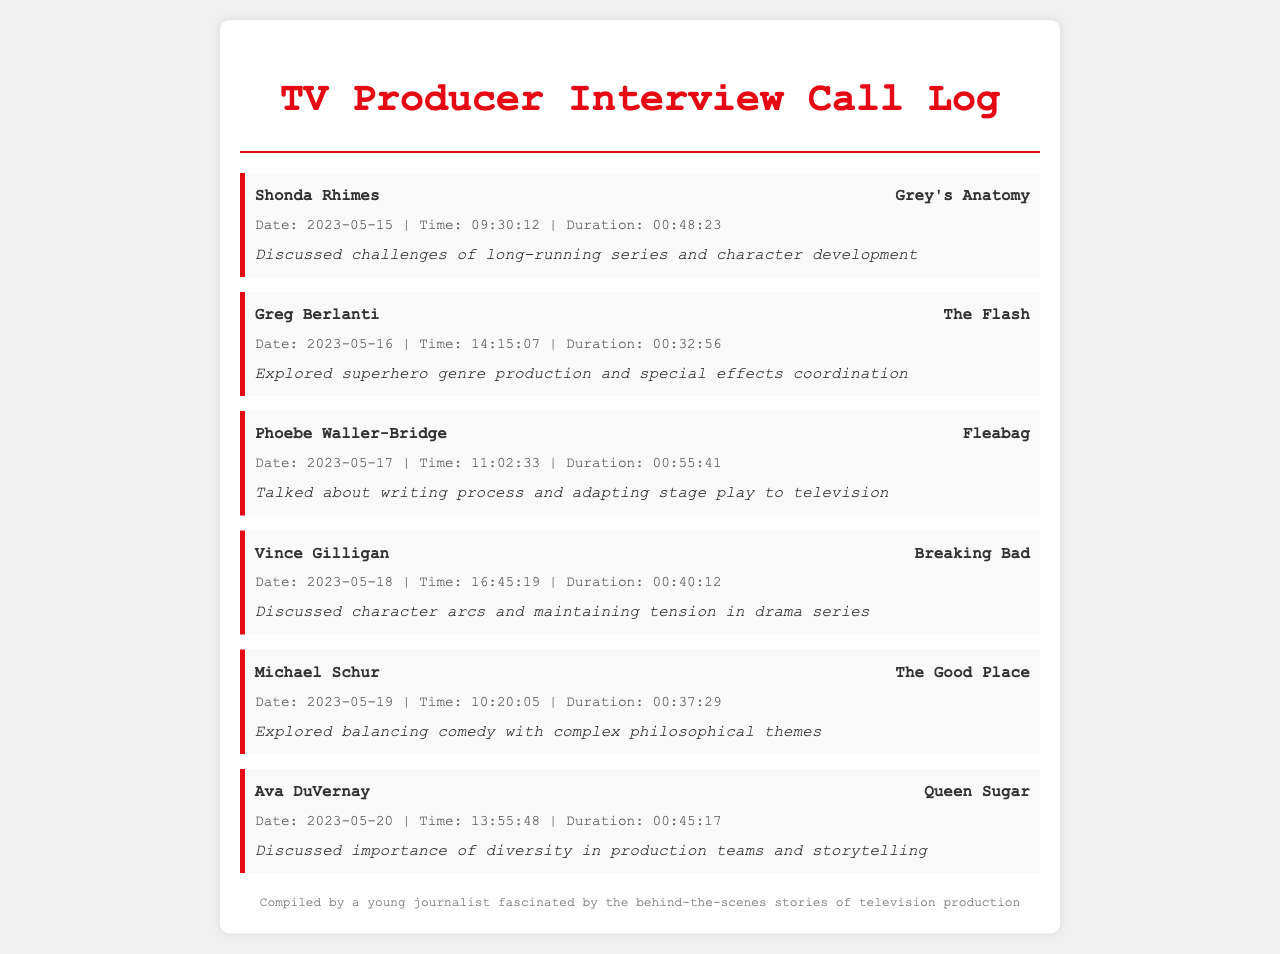What is the name of the producer interviewed on May 15, 2023? The document lists the interviews and associated details, including the producer's name for each call entry. The producer on that date is Shonda Rhimes.
Answer: Shonda Rhimes How long was the interview with Phoebe Waller-Bridge? The document provides the duration of each interview in the call details. The duration of the interview with Phoebe Waller-Bridge is mentioned explicitly.
Answer: 00:55:41 What show does Greg Berlanti produce? Each call entry specifies the producer's name and the show they work on, making it easy to identify shows associated with each producer. Greg Berlanti produces The Flash.
Answer: The Flash On what date did the interview with Ava DuVernay take place? The call log lists the date for each interview, enabling straightforward retrieval of that information for any specific producer. The date for Ava DuVernay's interview is provided in her entry.
Answer: 2023-05-20 Which producer discussed character arcs and maintaining tension in drama series? The document provides specific notes summarizing discussions in each interview, which helps identify topics covered by each producer effectively. The producer in this context is Vince Gilligan.
Answer: Vince Gilligan What is the total duration of interviews recorded in the document? The total duration can be calculated by adding up the individual durations given in each call entry, allowing for a comprehensive understanding of the total time spent in interviews.
Answer: 4 hours, 40 minutes How many producers are listed in the call log? The document can be scanned to count the number of unique call entries, each representing a different producer, revealing the total number at a glance.
Answer: 6 What theme did Michael Schur explore during his interview? Each call notes provides insight into the focus of the producer's interview, summarizing the specific themes discussed. Michael Schur explored balancing comedy with complex philosophical themes.
Answer: Balancing comedy with complex philosophical themes 